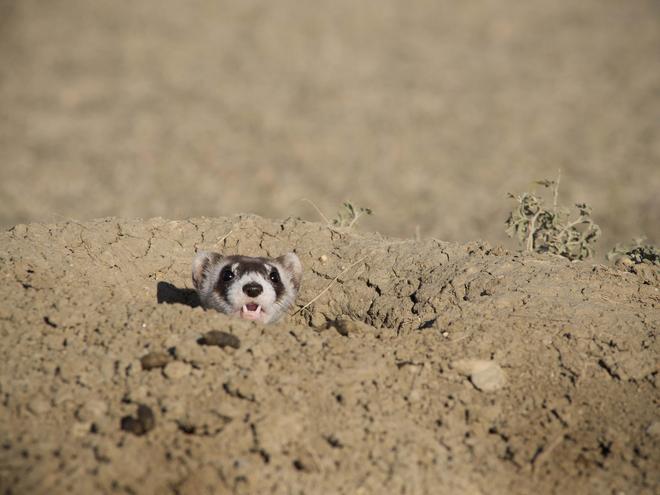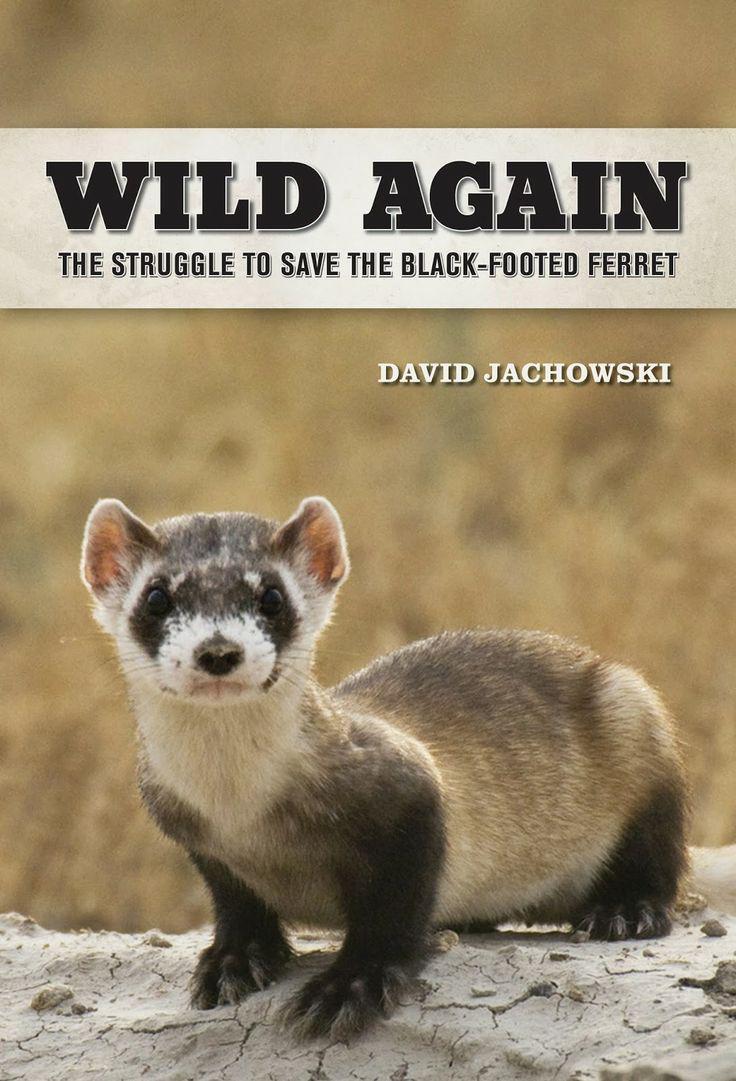The first image is the image on the left, the second image is the image on the right. Considering the images on both sides, is "A ferret is partially underground." valid? Answer yes or no. Yes. 